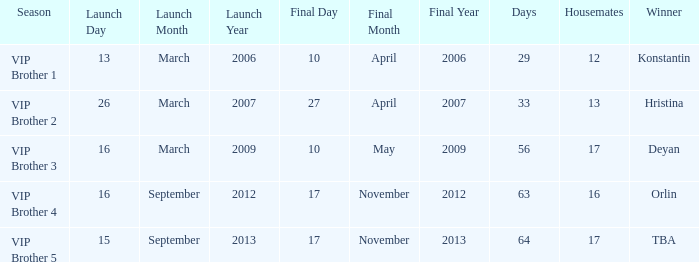What final date had 16 housemates? 17 November 2012. 